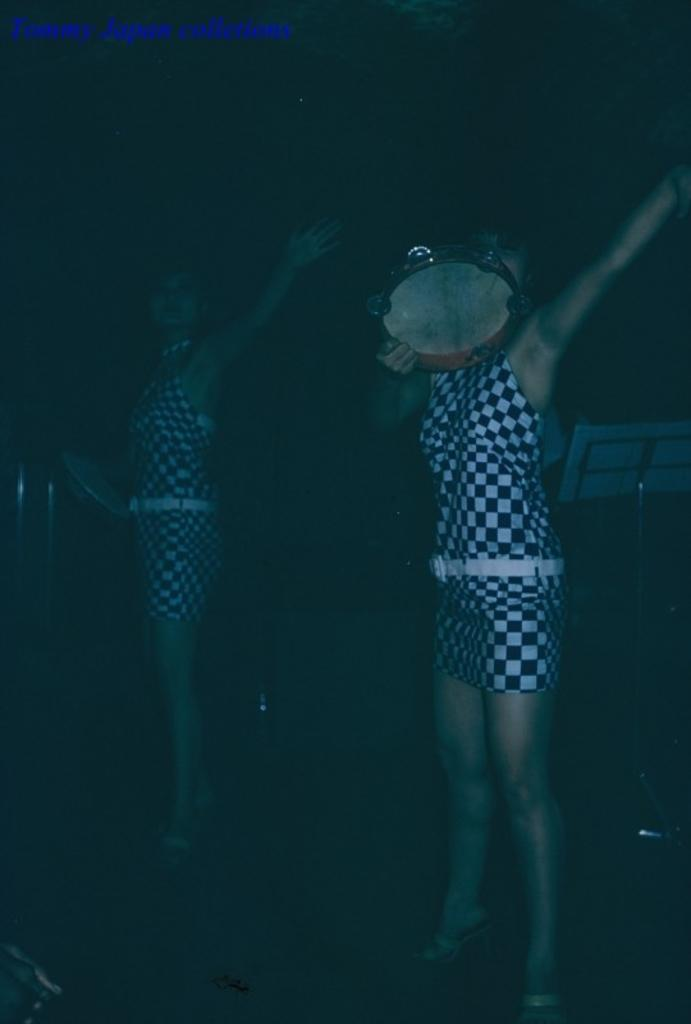How many people are in the image? There are two women in the image. What are the women doing in the image? The women are standing and holding a musical instrument in their hands. Can you describe any other objects or features in the background of the image? There are other objects in the background of the image, but their specific details are not mentioned in the provided facts. What type of reward is the woman on the left side of the image receiving for singing a song in the sleet? There is no mention of a reward, singing, or sleet in the provided facts. The image only shows two women standing and holding a musical instrument. 